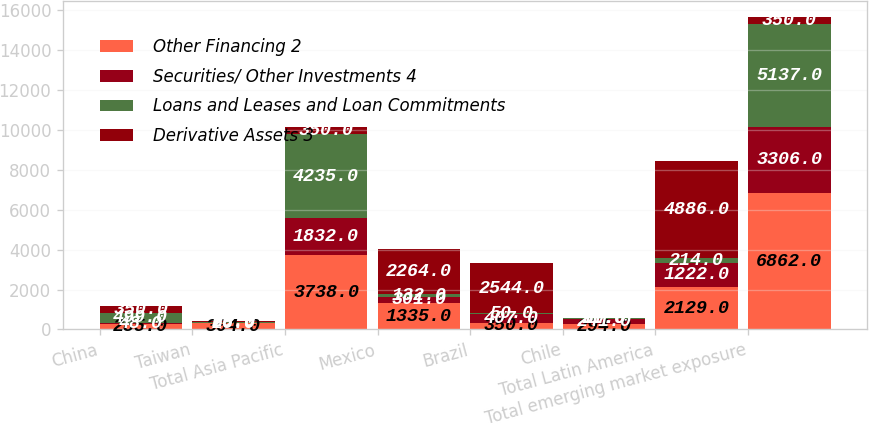Convert chart. <chart><loc_0><loc_0><loc_500><loc_500><stacked_bar_chart><ecel><fcel>China<fcel>Taiwan<fcel>Total Asia Pacific<fcel>Mexico<fcel>Brazil<fcel>Chile<fcel>Total Latin America<fcel>Total emerging market exposure<nl><fcel>Other Financing 2<fcel>285<fcel>304<fcel>3738<fcel>1335<fcel>350<fcel>294<fcel>2129<fcel>6862<nl><fcel>Securities/ Other Investments 4<fcel>48<fcel>26<fcel>1832<fcel>301<fcel>407<fcel>241<fcel>1222<fcel>3306<nl><fcel>Loans and Leases and Loan Commitments<fcel>499<fcel>60<fcel>4235<fcel>132<fcel>50<fcel>30<fcel>214<fcel>5137<nl><fcel>Derivative Assets 3<fcel>350<fcel>29<fcel>350<fcel>2264<fcel>2544<fcel>11<fcel>4886<fcel>350<nl></chart> 